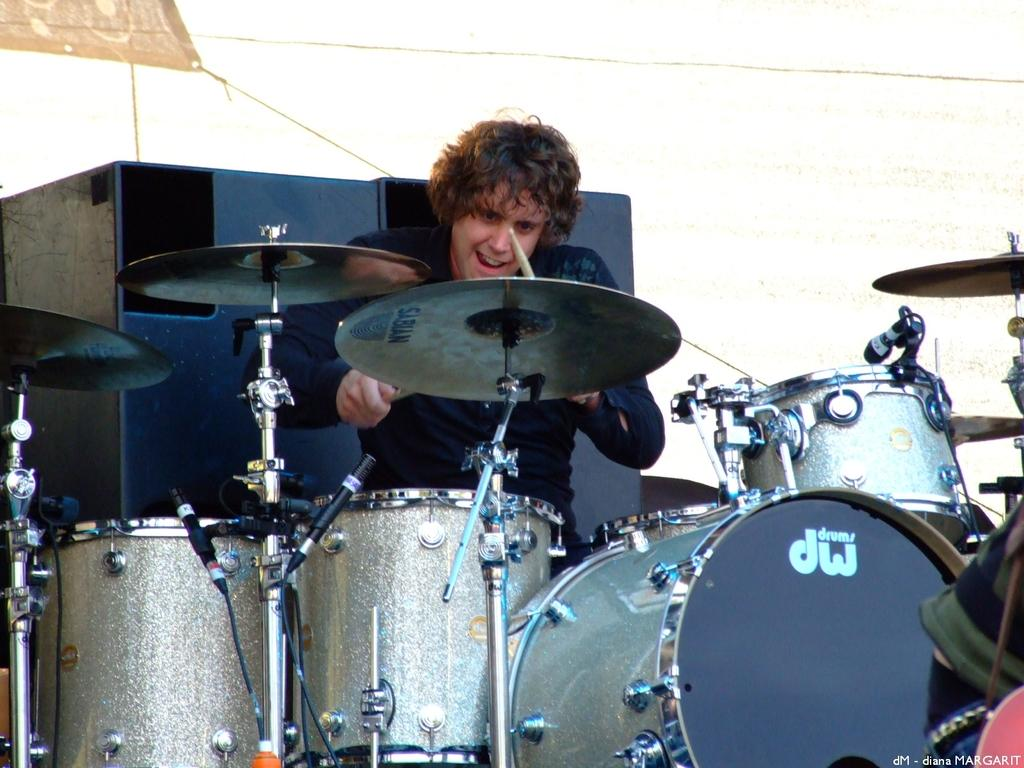What is the person in the image doing? The person is playing drums. What position is the person in while playing drums? The person is sitting. What color is the t-shirt the person is wearing? The person is wearing a dark blue color t-shirt. What can be seen in the background of the image? There is a big box in the background of the image. How many dimes are visible on the drum set in the image? There are no dimes visible on the drum set in the image. What route is the person taking while playing drums in the image? The image does not show the person taking any route, as they are sitting and playing drums in a stationary position. 